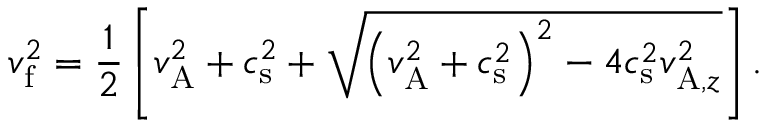<formula> <loc_0><loc_0><loc_500><loc_500>v _ { f } ^ { 2 } = \frac { 1 } { 2 } \left [ v _ { A } ^ { 2 } + c _ { s } ^ { 2 } + \sqrt { \left ( v _ { A } ^ { 2 } + c _ { s } ^ { 2 } \right ) ^ { 2 } - 4 c _ { s } ^ { 2 } v _ { A , z } ^ { 2 } } \right ] .</formula> 